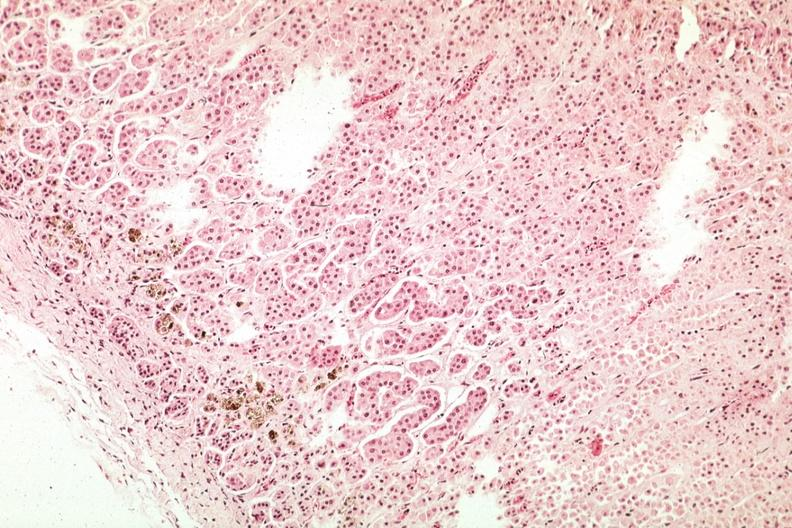does close-up tumor show pigment in area of zona glomerulosa?
Answer the question using a single word or phrase. No 